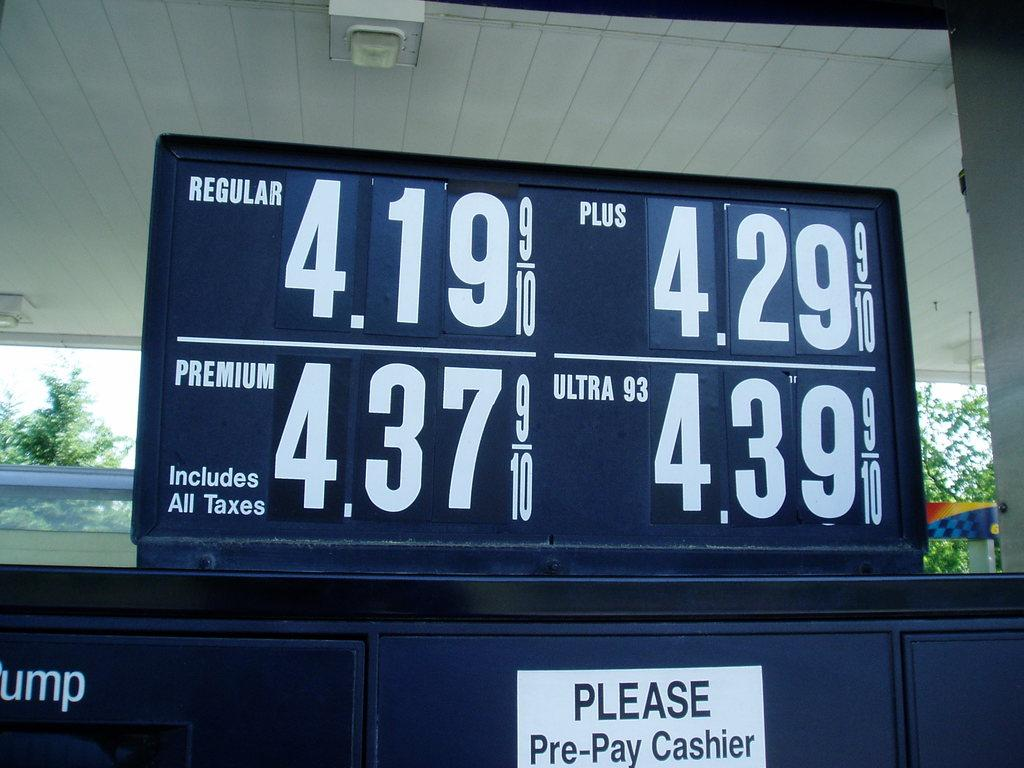<image>
Summarize the visual content of the image. Gasoline price Board and a please Pre-pay cashier notification underneath. 